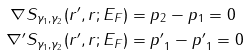Convert formula to latex. <formula><loc_0><loc_0><loc_500><loc_500>\nabla S _ { \gamma _ { 1 } , \gamma _ { 2 } } ( { r ^ { \prime } } , { r } ; E _ { F } ) & = { p } _ { 2 } - { p } _ { 1 } = 0 \\ \nabla ^ { \prime } S _ { \gamma _ { 1 } , \gamma _ { 2 } } ( { r ^ { \prime } } , { r } ; E _ { F } ) & = { p ^ { \prime } } _ { 1 } - { p ^ { \prime } } _ { 1 } = 0</formula> 